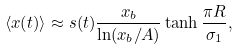<formula> <loc_0><loc_0><loc_500><loc_500>\langle x ( t ) \rangle \approx s ( t ) \frac { x _ { b } } { \ln ( x _ { b } / A ) } \tanh \frac { \pi R } { \sigma _ { 1 } } ,</formula> 